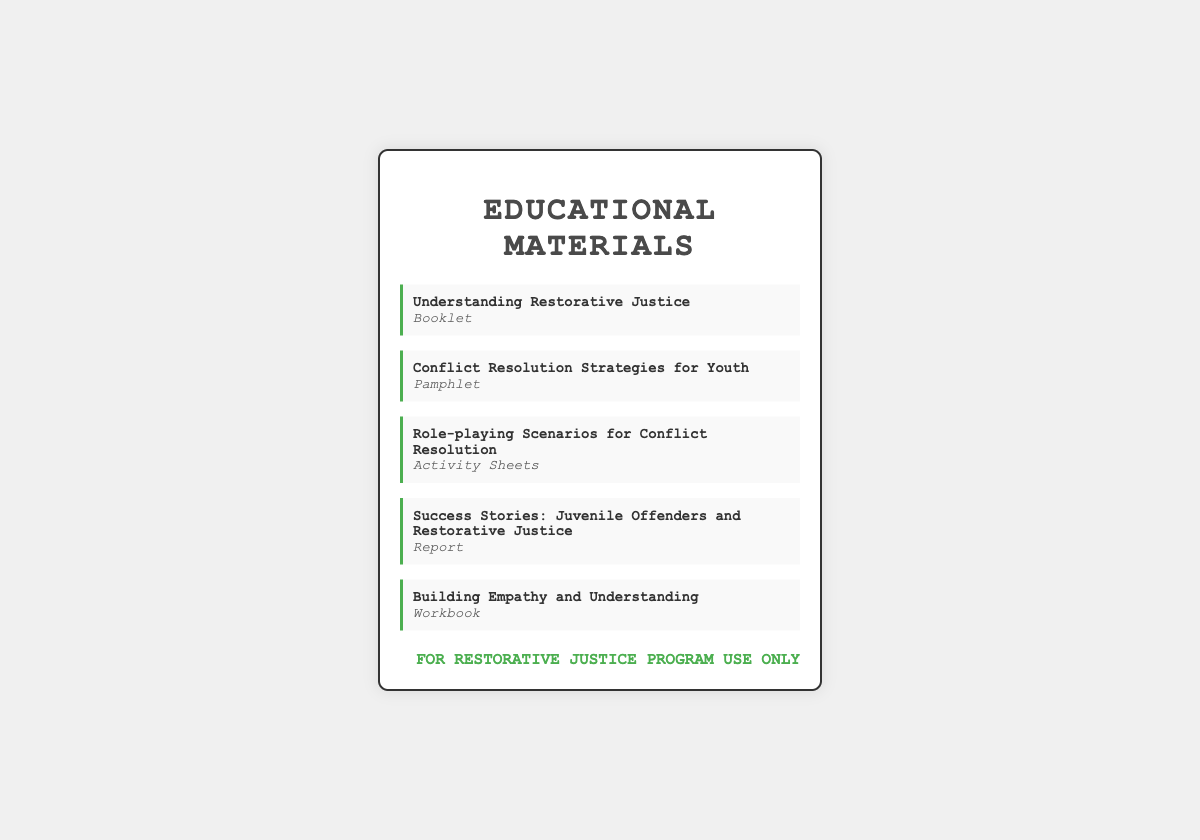What is the title of the first material? The first material listed in the shipping label is "Understanding Restorative Justice."
Answer: Understanding Restorative Justice What type of material is "Building Empathy and Understanding"? The material "Building Empathy and Understanding" is categorized as a workbook.
Answer: Workbook How many items are listed in the educational materials? There are five items listed in the materials section of the document.
Answer: 5 What is the purpose of the stamp at the bottom? The stamp at the bottom indicates that the materials are for "restorative justice program use only."
Answer: FOR RESTORATIVE JUSTICE PROGRAM USE ONLY Which material is a report? The material titled "Success Stories: Juvenile Offenders and Restorative Justice" is categorized as a report.
Answer: Success Stories: Juvenile Offenders and Restorative Justice What type of publication is "Conflict Resolution Strategies for Youth"? The publication titled "Conflict Resolution Strategies for Youth" is a pamphlet.
Answer: Pamphlet What does the presence of multiple types of materials suggest? The presence of multiple types suggests a variety of educational approaches for conflict resolution.
Answer: Variety of educational approaches Which item focuses on practical activities? The item focusing on practical activities is "Role-playing Scenarios for Conflict Resolution."
Answer: Role-playing Scenarios for Conflict Resolution 